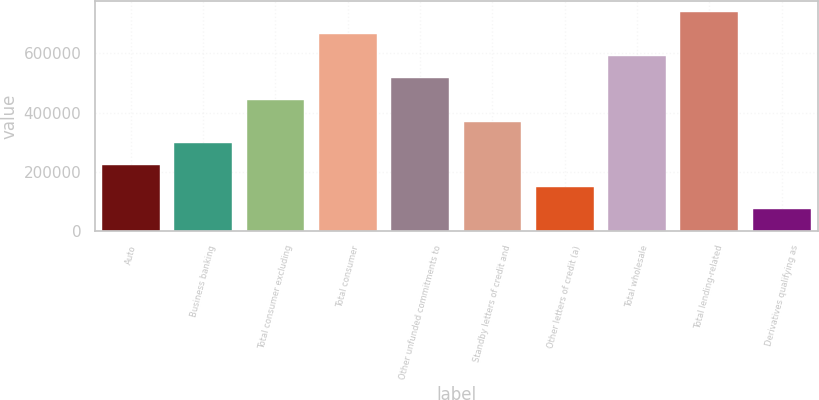Convert chart. <chart><loc_0><loc_0><loc_500><loc_500><bar_chart><fcel>Auto<fcel>Business banking<fcel>Total consumer excluding<fcel>Total consumer<fcel>Other unfunded commitments to<fcel>Standby letters of credit and<fcel>Other letters of credit (a)<fcel>Total wholesale<fcel>Total lending-related<fcel>Derivatives qualifying as<nl><fcel>221939<fcel>295701<fcel>443225<fcel>664510<fcel>516987<fcel>369463<fcel>148178<fcel>590748<fcel>738272<fcel>74415.8<nl></chart> 